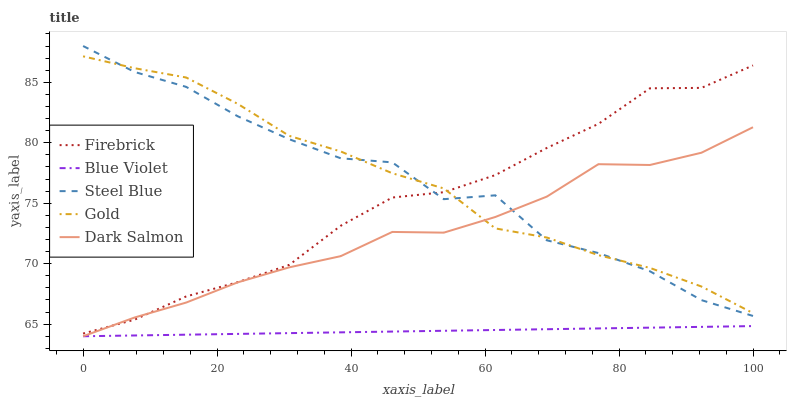Does Blue Violet have the minimum area under the curve?
Answer yes or no. Yes. Does Gold have the maximum area under the curve?
Answer yes or no. Yes. Does Firebrick have the minimum area under the curve?
Answer yes or no. No. Does Firebrick have the maximum area under the curve?
Answer yes or no. No. Is Blue Violet the smoothest?
Answer yes or no. Yes. Is Steel Blue the roughest?
Answer yes or no. Yes. Is Firebrick the smoothest?
Answer yes or no. No. Is Firebrick the roughest?
Answer yes or no. No. Does Firebrick have the lowest value?
Answer yes or no. No. Does Firebrick have the highest value?
Answer yes or no. No. Is Blue Violet less than Gold?
Answer yes or no. Yes. Is Gold greater than Blue Violet?
Answer yes or no. Yes. Does Blue Violet intersect Gold?
Answer yes or no. No. 